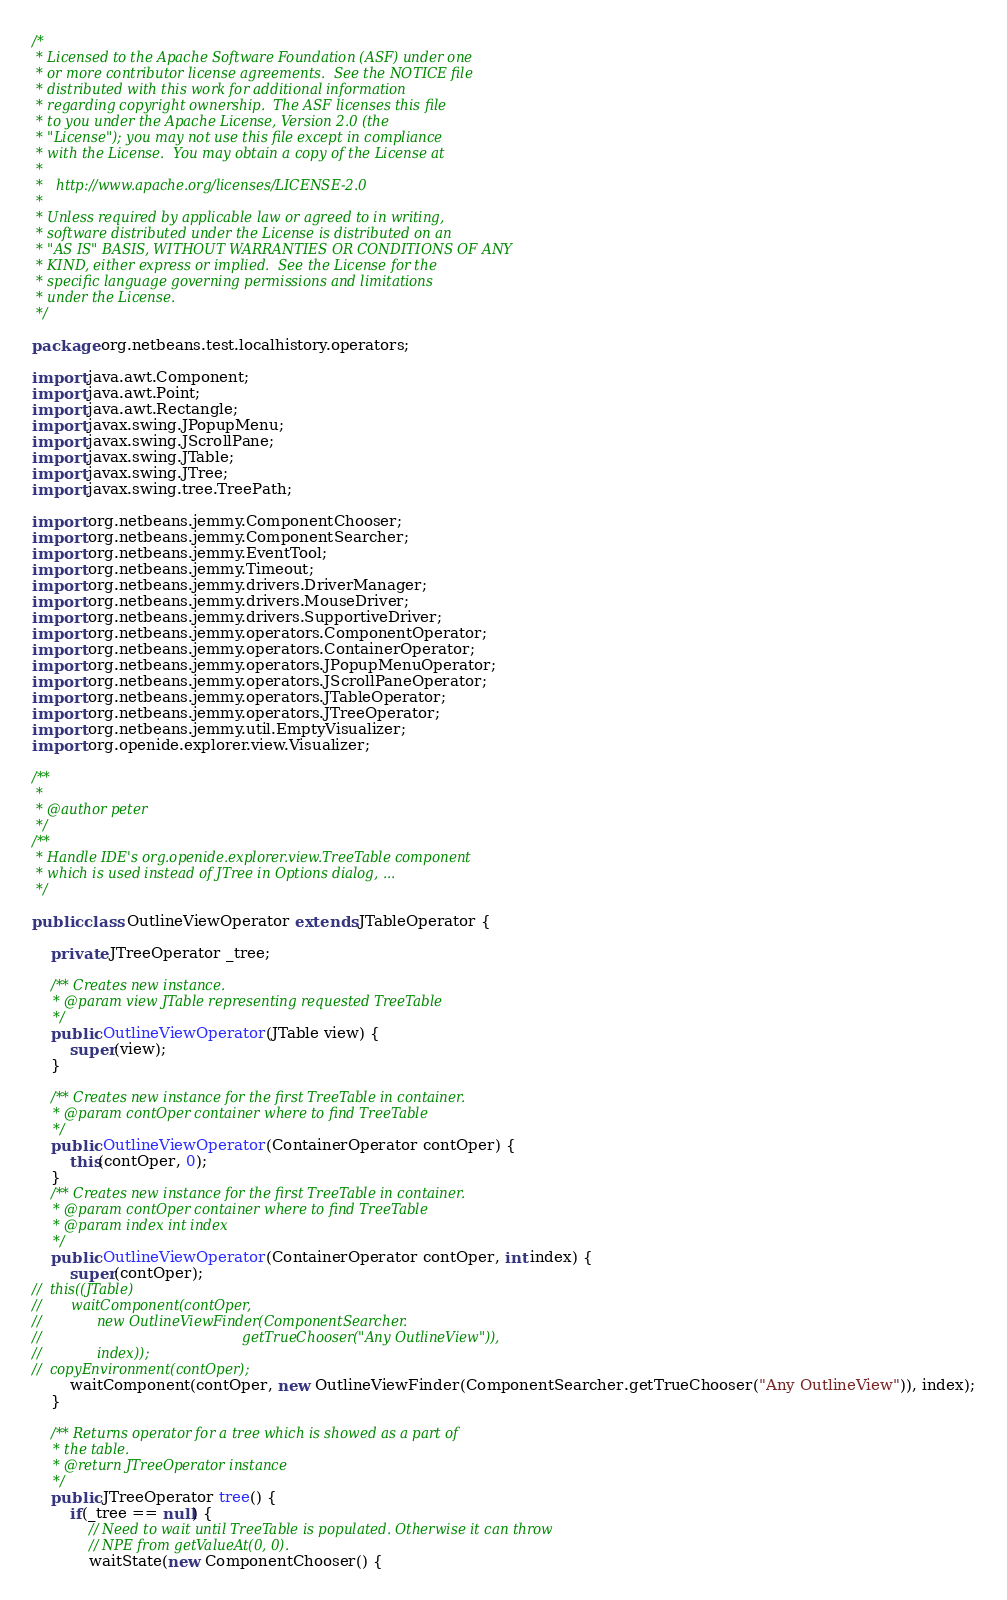<code> <loc_0><loc_0><loc_500><loc_500><_Java_>/*
 * Licensed to the Apache Software Foundation (ASF) under one
 * or more contributor license agreements.  See the NOTICE file
 * distributed with this work for additional information
 * regarding copyright ownership.  The ASF licenses this file
 * to you under the Apache License, Version 2.0 (the
 * "License"); you may not use this file except in compliance
 * with the License.  You may obtain a copy of the License at
 *
 *   http://www.apache.org/licenses/LICENSE-2.0
 *
 * Unless required by applicable law or agreed to in writing,
 * software distributed under the License is distributed on an
 * "AS IS" BASIS, WITHOUT WARRANTIES OR CONDITIONS OF ANY
 * KIND, either express or implied.  See the License for the
 * specific language governing permissions and limitations
 * under the License.
 */

package org.netbeans.test.localhistory.operators;

import java.awt.Component;
import java.awt.Point;
import java.awt.Rectangle;
import javax.swing.JPopupMenu;
import javax.swing.JScrollPane;
import javax.swing.JTable;
import javax.swing.JTree;
import javax.swing.tree.TreePath;

import org.netbeans.jemmy.ComponentChooser;
import org.netbeans.jemmy.ComponentSearcher;
import org.netbeans.jemmy.EventTool;
import org.netbeans.jemmy.Timeout;
import org.netbeans.jemmy.drivers.DriverManager;
import org.netbeans.jemmy.drivers.MouseDriver;
import org.netbeans.jemmy.drivers.SupportiveDriver;
import org.netbeans.jemmy.operators.ComponentOperator;
import org.netbeans.jemmy.operators.ContainerOperator;
import org.netbeans.jemmy.operators.JPopupMenuOperator;
import org.netbeans.jemmy.operators.JScrollPaneOperator;
import org.netbeans.jemmy.operators.JTableOperator;
import org.netbeans.jemmy.operators.JTreeOperator;
import org.netbeans.jemmy.util.EmptyVisualizer;
import org.openide.explorer.view.Visualizer;

/**
 *
 * @author peter
 */
/**
 * Handle IDE's org.openide.explorer.view.TreeTable component
 * which is used instead of JTree in Options dialog, ...
 */

public class OutlineViewOperator extends JTableOperator {

    private JTreeOperator _tree;

    /** Creates new instance.
     * @param view JTable representing requested TreeTable
     */
    public OutlineViewOperator(JTable view) {
        super(view);
    }

    /** Creates new instance for the first TreeTable in container.
     * @param contOper container where to find TreeTable
     */
    public OutlineViewOperator(ContainerOperator contOper) {
        this(contOper, 0);
    }
    /** Creates new instance for the first TreeTable in container.
     * @param contOper container where to find TreeTable
     * @param index int index
     */
    public OutlineViewOperator(ContainerOperator contOper, int index) {
        super(contOper);
//	this((JTable)
//	     waitComponent(contOper,
//			   new OutlineViewFinder(ComponentSearcher.
//                                               getTrueChooser("Any OutlineView")),
//			   index));
//	copyEnvironment(contOper);
        waitComponent(contOper, new OutlineViewFinder(ComponentSearcher.getTrueChooser("Any OutlineView")), index);
    }

    /** Returns operator for a tree which is showed as a part of
     * the table.
     * @return JTreeOperator instance
     */
    public JTreeOperator tree() {
        if(_tree == null) {
            // Need to wait until TreeTable is populated. Otherwise it can throw
            // NPE from getValueAt(0, 0).
            waitState(new ComponentChooser() {</code> 